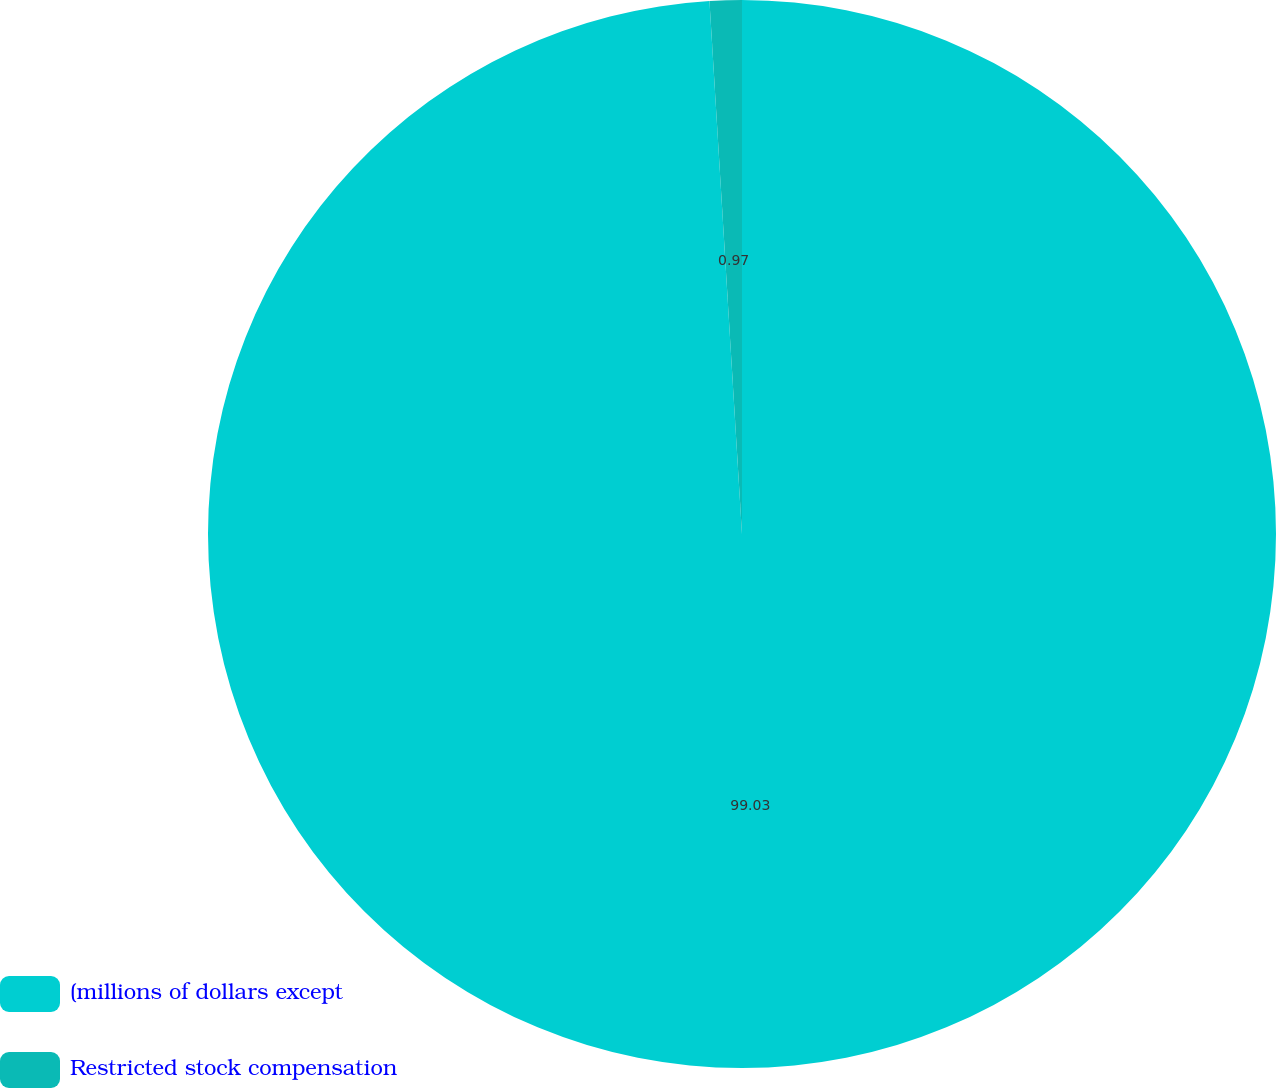Convert chart to OTSL. <chart><loc_0><loc_0><loc_500><loc_500><pie_chart><fcel>(millions of dollars except<fcel>Restricted stock compensation<nl><fcel>99.03%<fcel>0.97%<nl></chart> 